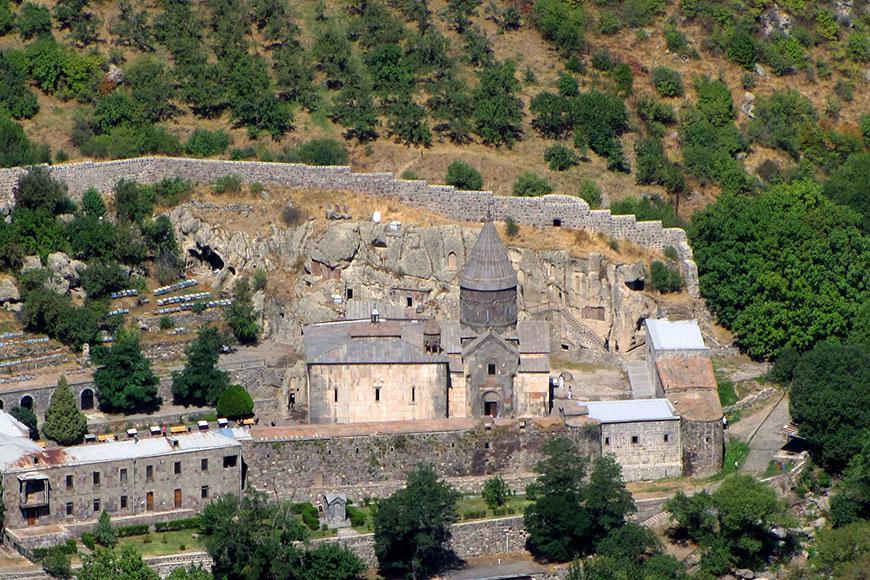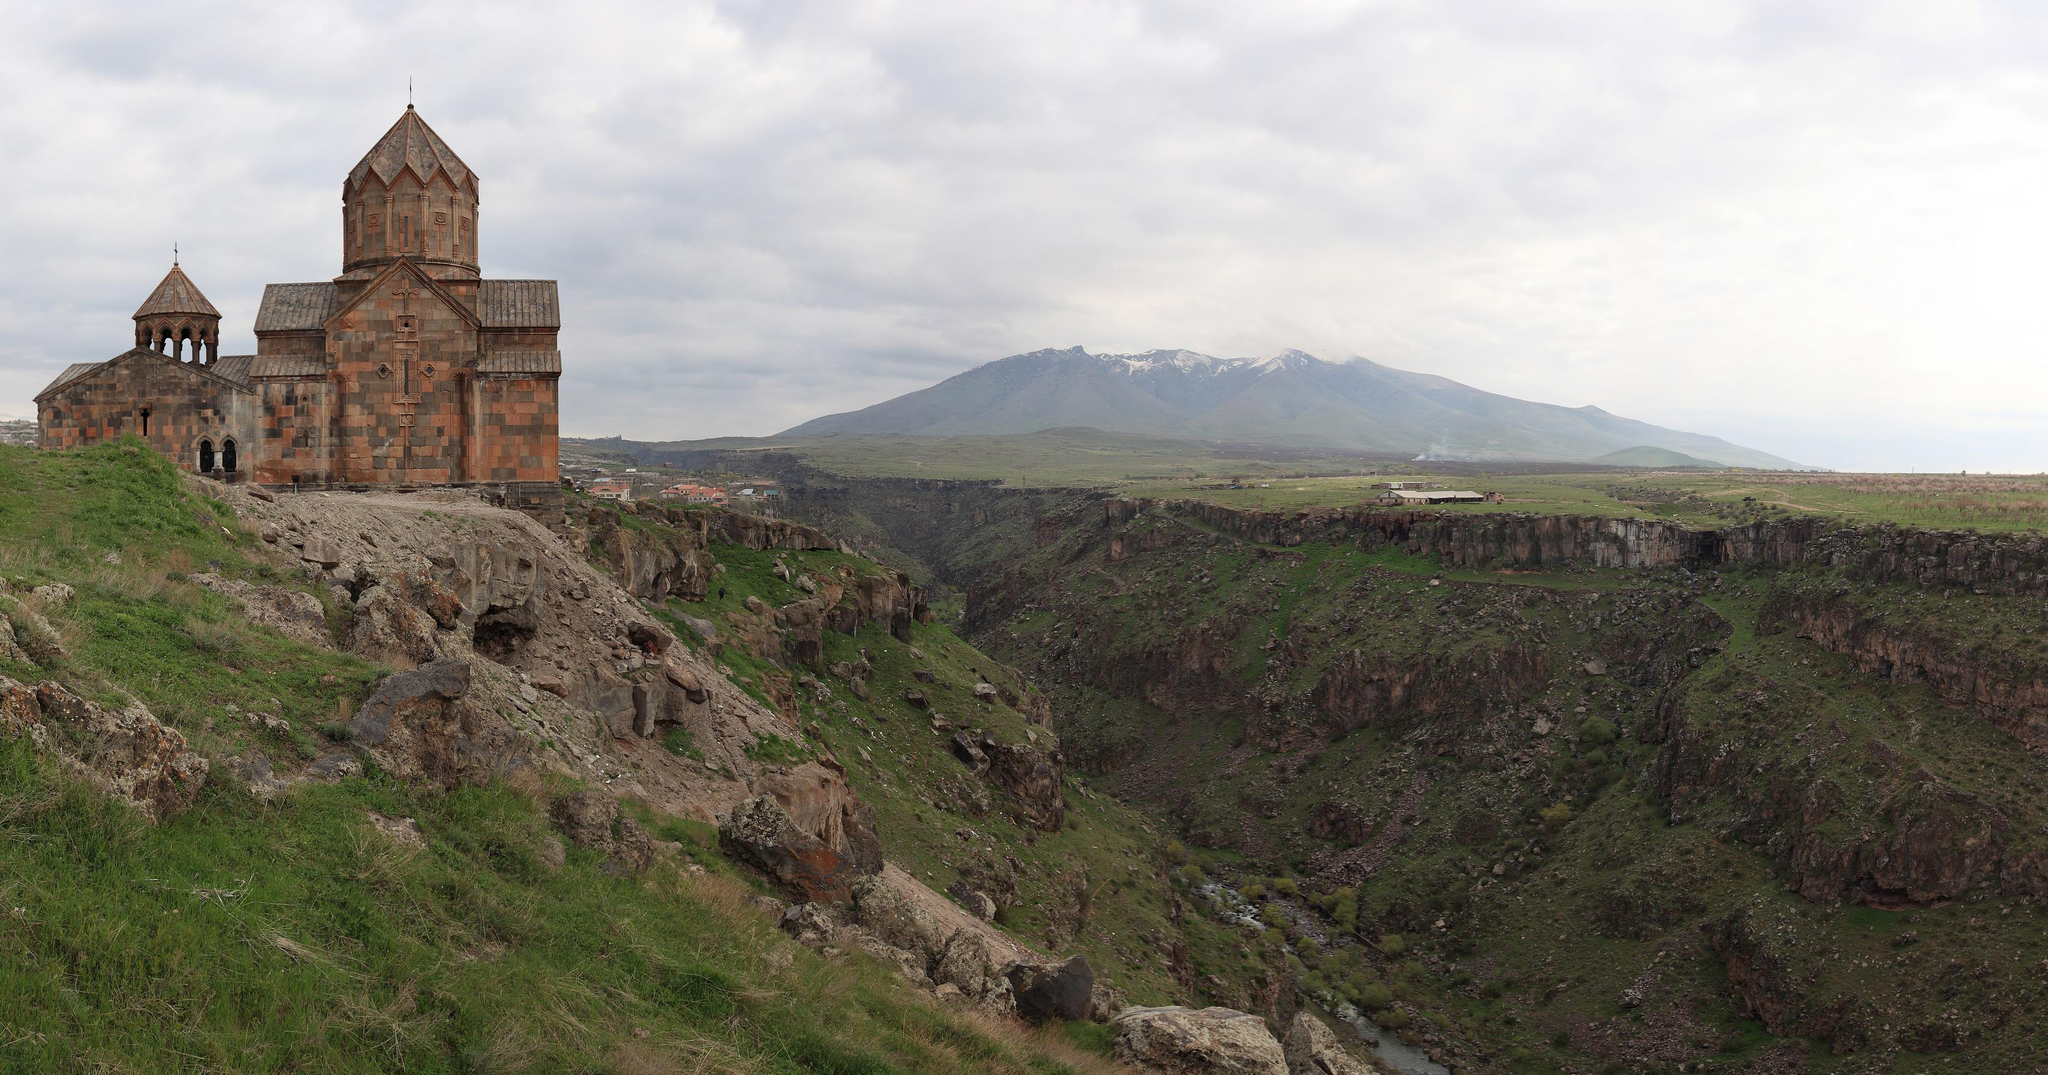The first image is the image on the left, the second image is the image on the right. For the images shown, is this caption "There is a cross atop the building in one of the images." true? Answer yes or no. No. 